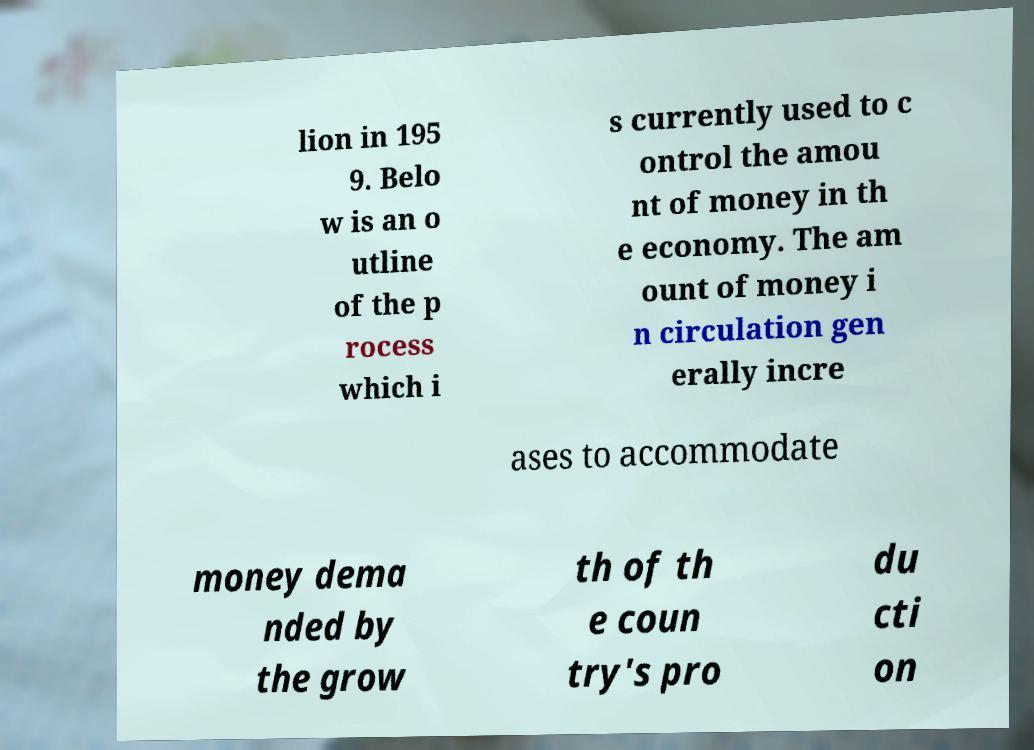Can you accurately transcribe the text from the provided image for me? lion in 195 9. Belo w is an o utline of the p rocess which i s currently used to c ontrol the amou nt of money in th e economy. The am ount of money i n circulation gen erally incre ases to accommodate money dema nded by the grow th of th e coun try's pro du cti on 